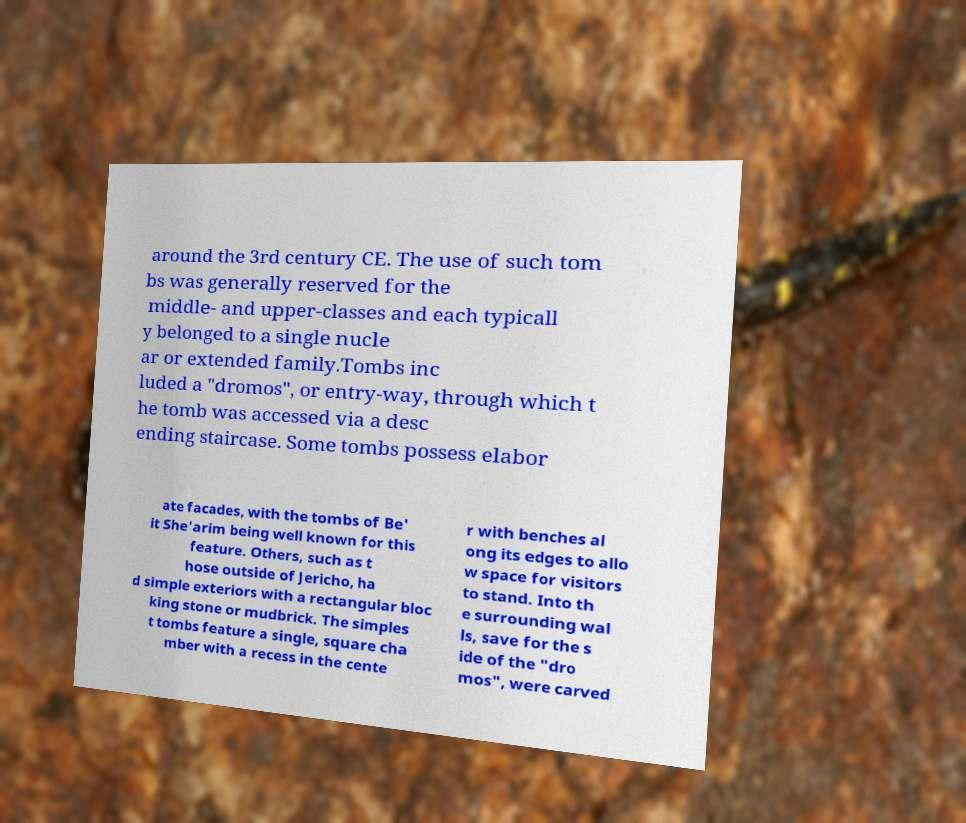Please read and relay the text visible in this image. What does it say? around the 3rd century CE. The use of such tom bs was generally reserved for the middle- and upper-classes and each typicall y belonged to a single nucle ar or extended family.Tombs inc luded a "dromos", or entry-way, through which t he tomb was accessed via a desc ending staircase. Some tombs possess elabor ate facades, with the tombs of Be' it She'arim being well known for this feature. Others, such as t hose outside of Jericho, ha d simple exteriors with a rectangular bloc king stone or mudbrick. The simples t tombs feature a single, square cha mber with a recess in the cente r with benches al ong its edges to allo w space for visitors to stand. Into th e surrounding wal ls, save for the s ide of the "dro mos", were carved 